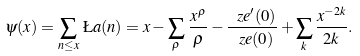Convert formula to latex. <formula><loc_0><loc_0><loc_500><loc_500>\psi ( x ) = \sum _ { n \leq x } \, \L a ( n ) = x - \sum _ { \rho } \, \frac { x ^ { \rho } } { \rho } - \frac { \ z e ^ { \prime } ( 0 ) } { \ z e ( 0 ) } + \sum _ { k } \frac { x ^ { - 2 k } } { 2 k } .</formula> 